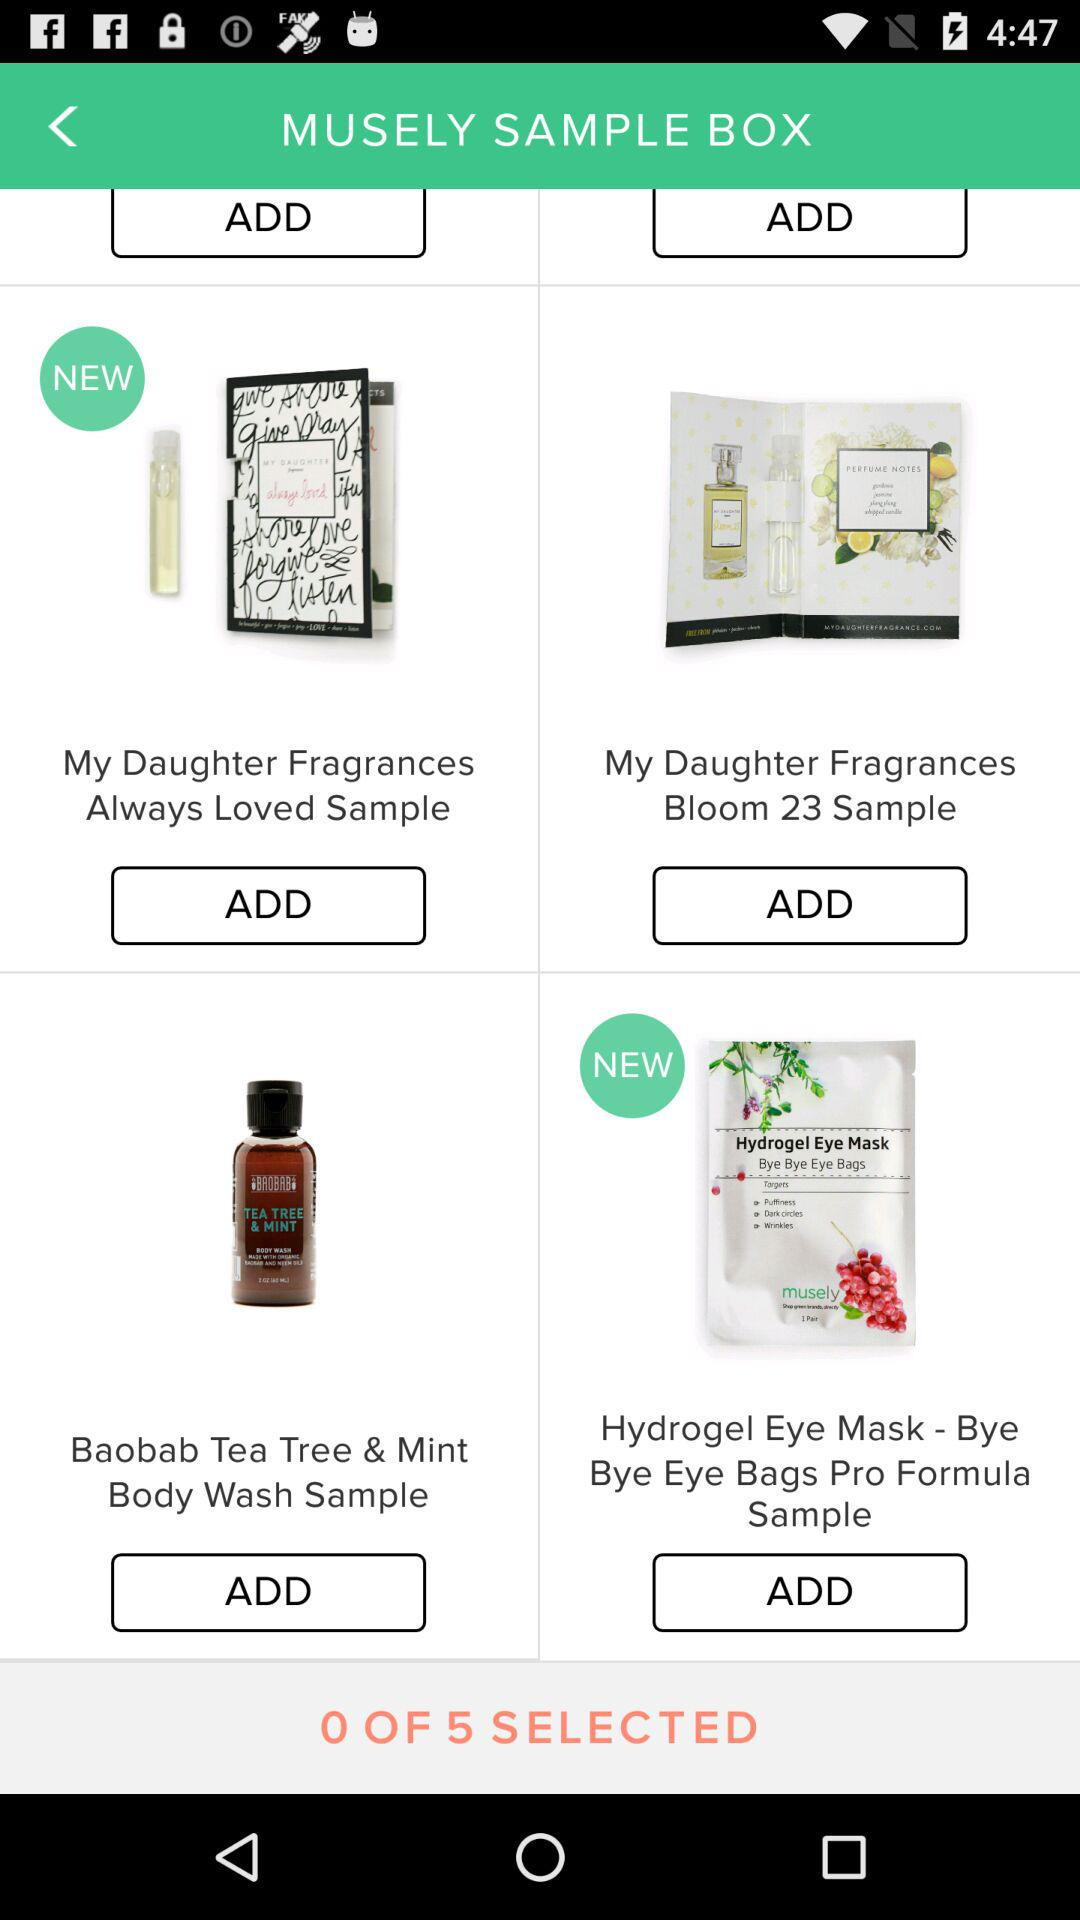How many items are there in the sample box?
Answer the question using a single word or phrase. 5 